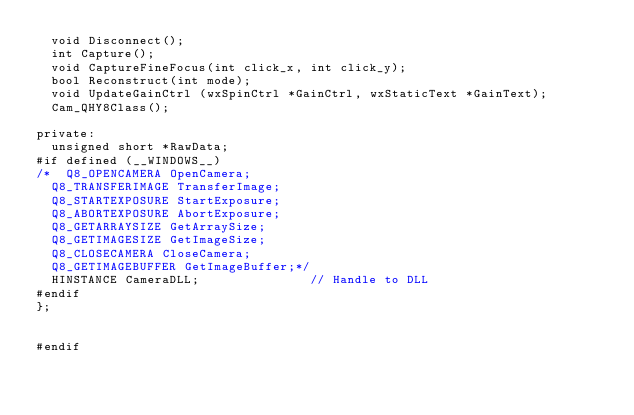<code> <loc_0><loc_0><loc_500><loc_500><_C_>	void Disconnect();
	int Capture();
	void CaptureFineFocus(int click_x, int click_y);
	bool Reconstruct(int mode);
	void UpdateGainCtrl (wxSpinCtrl *GainCtrl, wxStaticText *GainText);
	Cam_QHY8Class();

private:
	unsigned short *RawData;
#if defined (__WINDOWS__)
/*	Q8_OPENCAMERA OpenCamera;
	Q8_TRANSFERIMAGE TransferImage;
	Q8_STARTEXPOSURE StartExposure;
	Q8_ABORTEXPOSURE AbortExposure;
	Q8_GETARRAYSIZE GetArraySize;
	Q8_GETIMAGESIZE GetImageSize;
	Q8_CLOSECAMERA CloseCamera;
	Q8_GETIMAGEBUFFER GetImageBuffer;*/
	HINSTANCE CameraDLL;               // Handle to DLL
#endif
};


#endif
</code> 